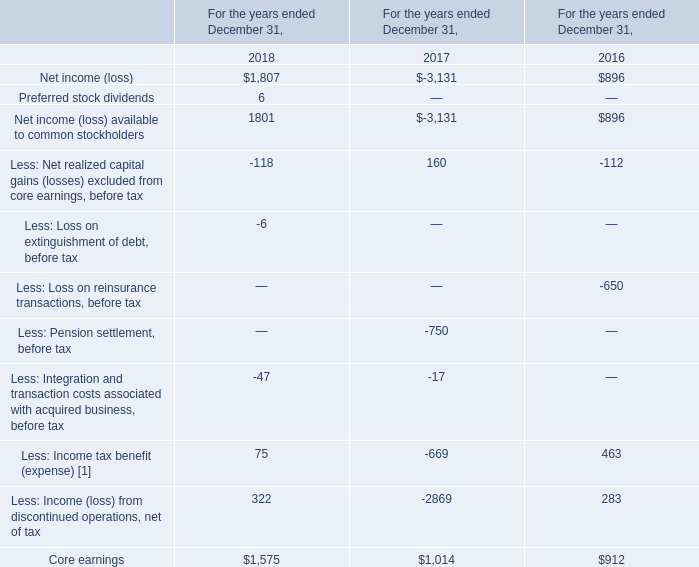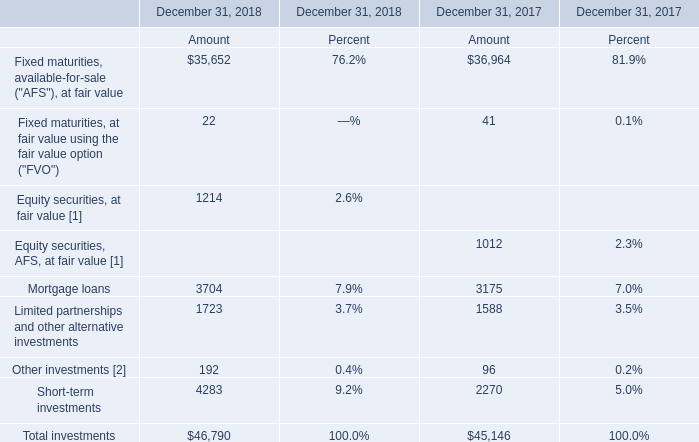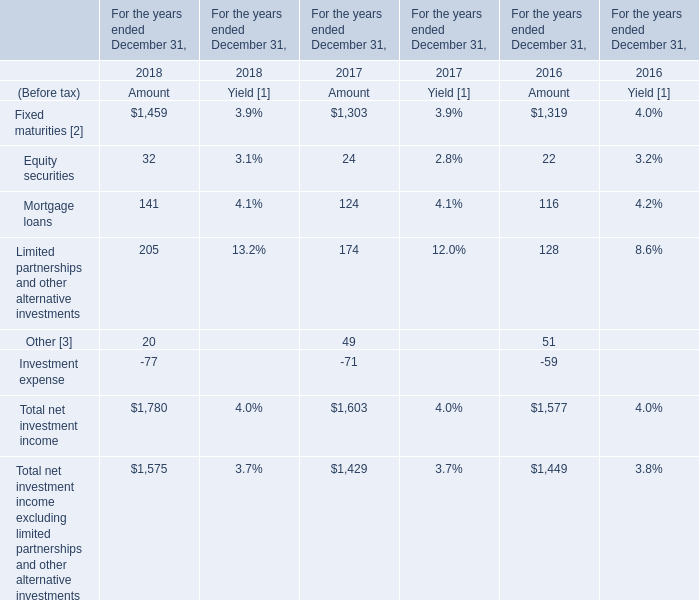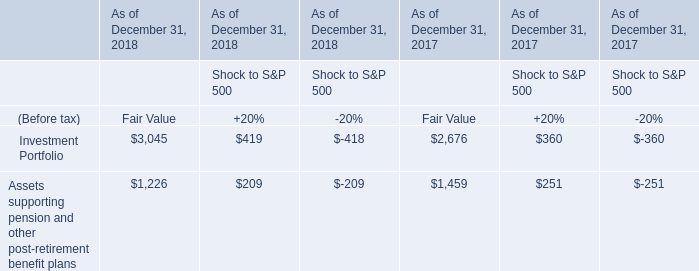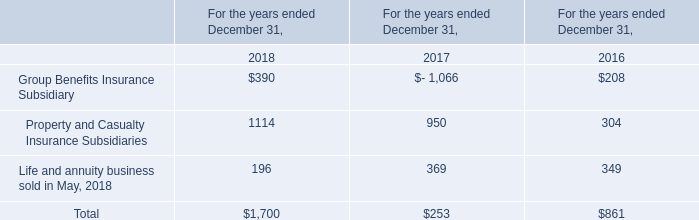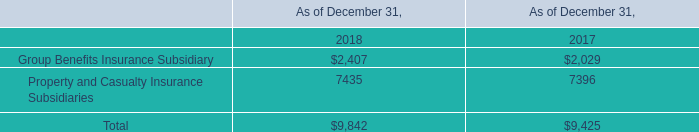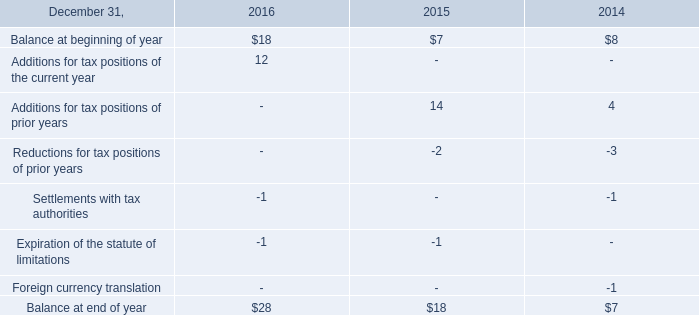What is the average amount of Core earnings of For the years ended December 31, 2018, and Mortgage loans of December 31, 2017 Amount ? 
Computations: ((1575.0 + 3175.0) / 2)
Answer: 2375.0. 